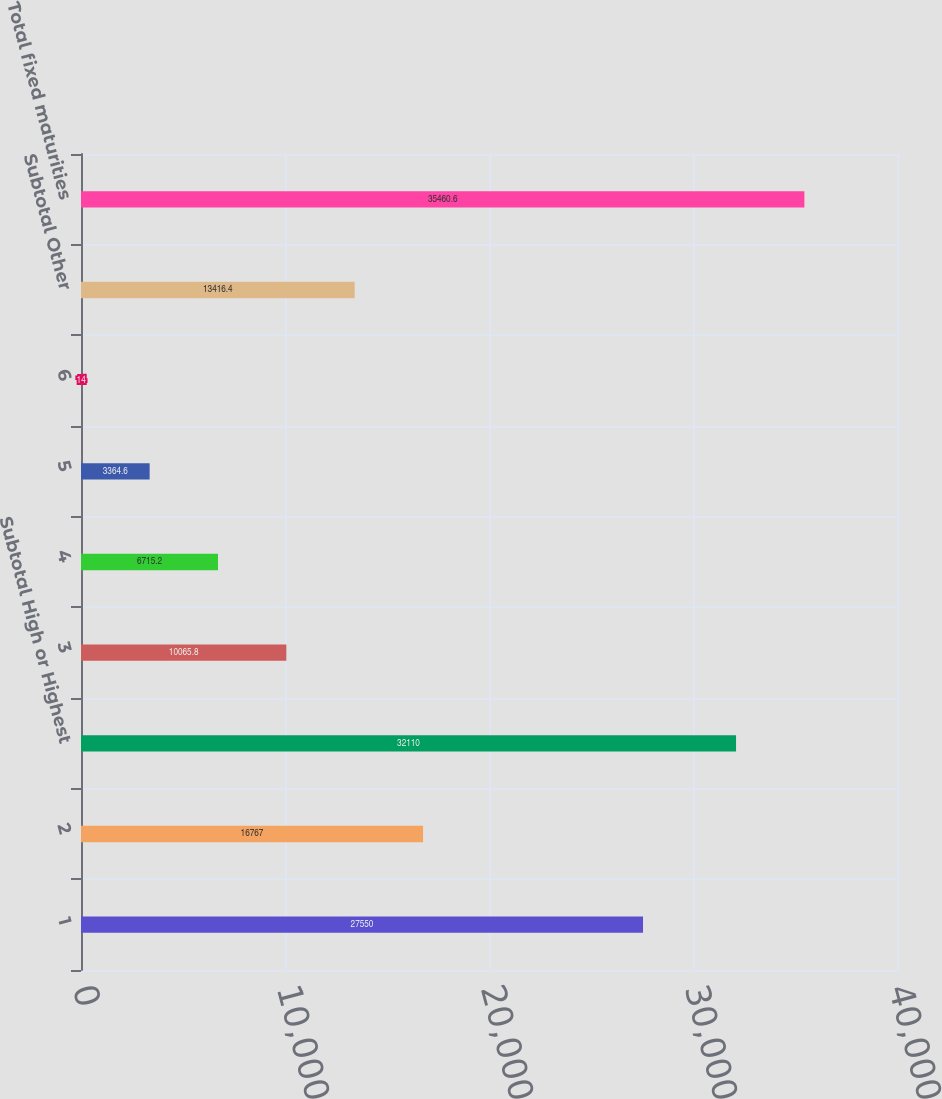Convert chart. <chart><loc_0><loc_0><loc_500><loc_500><bar_chart><fcel>1<fcel>2<fcel>Subtotal High or Highest<fcel>3<fcel>4<fcel>5<fcel>6<fcel>Subtotal Other<fcel>Total fixed maturities<nl><fcel>27550<fcel>16767<fcel>32110<fcel>10065.8<fcel>6715.2<fcel>3364.6<fcel>14<fcel>13416.4<fcel>35460.6<nl></chart> 